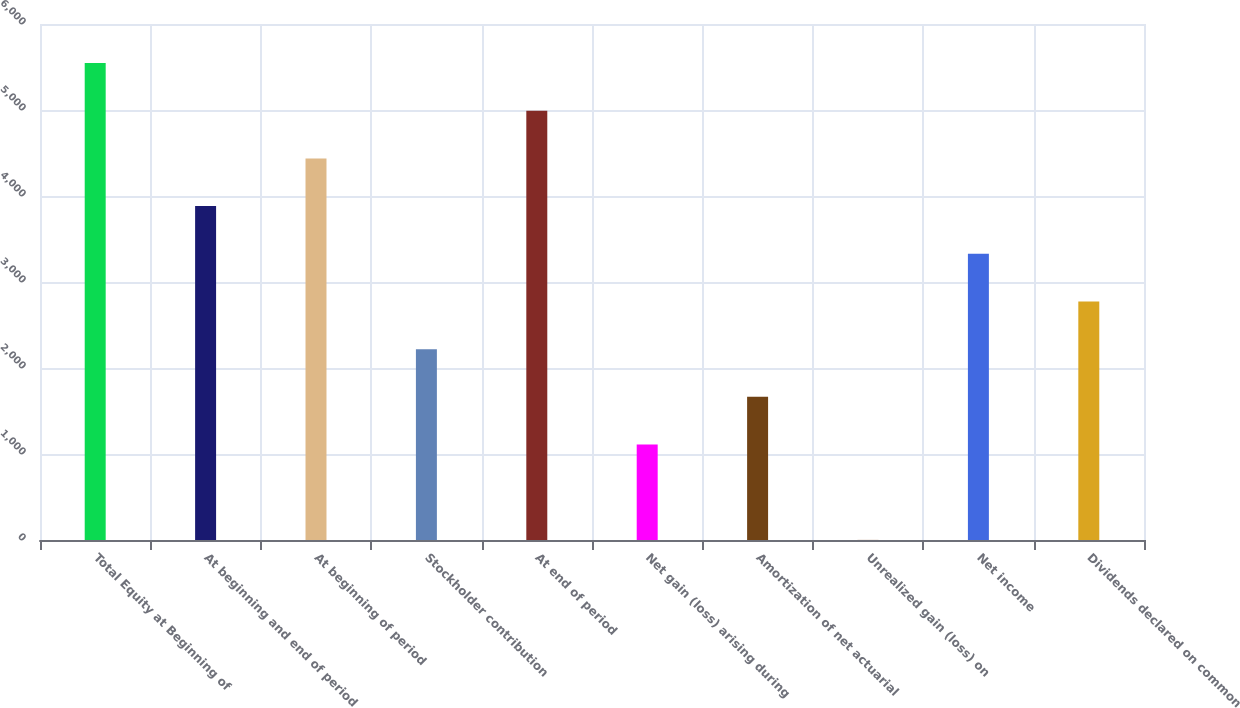Convert chart to OTSL. <chart><loc_0><loc_0><loc_500><loc_500><bar_chart><fcel>Total Equity at Beginning of<fcel>At beginning and end of period<fcel>At beginning of period<fcel>Stockholder contribution<fcel>At end of period<fcel>Net gain (loss) arising during<fcel>Amortization of net actuarial<fcel>Unrealized gain (loss) on<fcel>Net income<fcel>Dividends declared on common<nl><fcel>5546<fcel>3882.5<fcel>4437<fcel>2219<fcel>4991.5<fcel>1110<fcel>1664.5<fcel>1<fcel>3328<fcel>2773.5<nl></chart> 